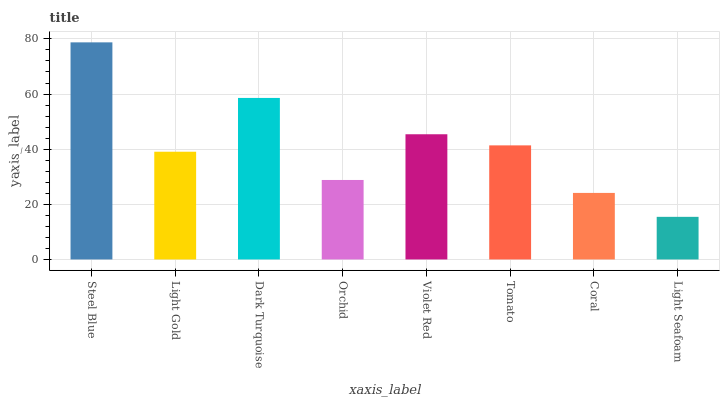Is Light Gold the minimum?
Answer yes or no. No. Is Light Gold the maximum?
Answer yes or no. No. Is Steel Blue greater than Light Gold?
Answer yes or no. Yes. Is Light Gold less than Steel Blue?
Answer yes or no. Yes. Is Light Gold greater than Steel Blue?
Answer yes or no. No. Is Steel Blue less than Light Gold?
Answer yes or no. No. Is Tomato the high median?
Answer yes or no. Yes. Is Light Gold the low median?
Answer yes or no. Yes. Is Light Seafoam the high median?
Answer yes or no. No. Is Orchid the low median?
Answer yes or no. No. 